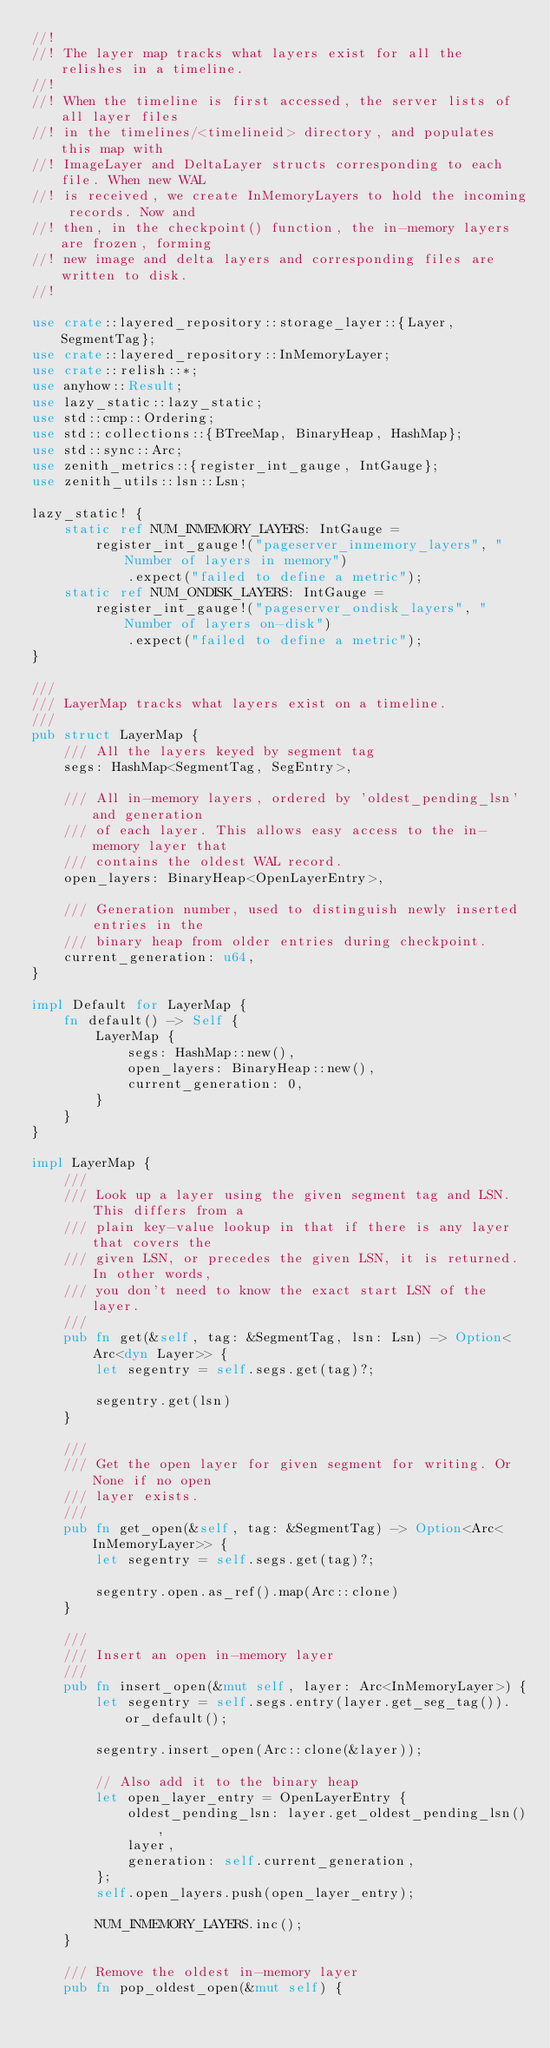Convert code to text. <code><loc_0><loc_0><loc_500><loc_500><_Rust_>//!
//! The layer map tracks what layers exist for all the relishes in a timeline.
//!
//! When the timeline is first accessed, the server lists of all layer files
//! in the timelines/<timelineid> directory, and populates this map with
//! ImageLayer and DeltaLayer structs corresponding to each file. When new WAL
//! is received, we create InMemoryLayers to hold the incoming records. Now and
//! then, in the checkpoint() function, the in-memory layers are frozen, forming
//! new image and delta layers and corresponding files are written to disk.
//!

use crate::layered_repository::storage_layer::{Layer, SegmentTag};
use crate::layered_repository::InMemoryLayer;
use crate::relish::*;
use anyhow::Result;
use lazy_static::lazy_static;
use std::cmp::Ordering;
use std::collections::{BTreeMap, BinaryHeap, HashMap};
use std::sync::Arc;
use zenith_metrics::{register_int_gauge, IntGauge};
use zenith_utils::lsn::Lsn;

lazy_static! {
    static ref NUM_INMEMORY_LAYERS: IntGauge =
        register_int_gauge!("pageserver_inmemory_layers", "Number of layers in memory")
            .expect("failed to define a metric");
    static ref NUM_ONDISK_LAYERS: IntGauge =
        register_int_gauge!("pageserver_ondisk_layers", "Number of layers on-disk")
            .expect("failed to define a metric");
}

///
/// LayerMap tracks what layers exist on a timeline.
///
pub struct LayerMap {
    /// All the layers keyed by segment tag
    segs: HashMap<SegmentTag, SegEntry>,

    /// All in-memory layers, ordered by 'oldest_pending_lsn' and generation
    /// of each layer. This allows easy access to the in-memory layer that
    /// contains the oldest WAL record.
    open_layers: BinaryHeap<OpenLayerEntry>,

    /// Generation number, used to distinguish newly inserted entries in the
    /// binary heap from older entries during checkpoint.
    current_generation: u64,
}

impl Default for LayerMap {
    fn default() -> Self {
        LayerMap {
            segs: HashMap::new(),
            open_layers: BinaryHeap::new(),
            current_generation: 0,
        }
    }
}

impl LayerMap {
    ///
    /// Look up a layer using the given segment tag and LSN. This differs from a
    /// plain key-value lookup in that if there is any layer that covers the
    /// given LSN, or precedes the given LSN, it is returned. In other words,
    /// you don't need to know the exact start LSN of the layer.
    ///
    pub fn get(&self, tag: &SegmentTag, lsn: Lsn) -> Option<Arc<dyn Layer>> {
        let segentry = self.segs.get(tag)?;

        segentry.get(lsn)
    }

    ///
    /// Get the open layer for given segment for writing. Or None if no open
    /// layer exists.
    ///
    pub fn get_open(&self, tag: &SegmentTag) -> Option<Arc<InMemoryLayer>> {
        let segentry = self.segs.get(tag)?;

        segentry.open.as_ref().map(Arc::clone)
    }

    ///
    /// Insert an open in-memory layer
    ///
    pub fn insert_open(&mut self, layer: Arc<InMemoryLayer>) {
        let segentry = self.segs.entry(layer.get_seg_tag()).or_default();

        segentry.insert_open(Arc::clone(&layer));

        // Also add it to the binary heap
        let open_layer_entry = OpenLayerEntry {
            oldest_pending_lsn: layer.get_oldest_pending_lsn(),
            layer,
            generation: self.current_generation,
        };
        self.open_layers.push(open_layer_entry);

        NUM_INMEMORY_LAYERS.inc();
    }

    /// Remove the oldest in-memory layer
    pub fn pop_oldest_open(&mut self) {</code> 